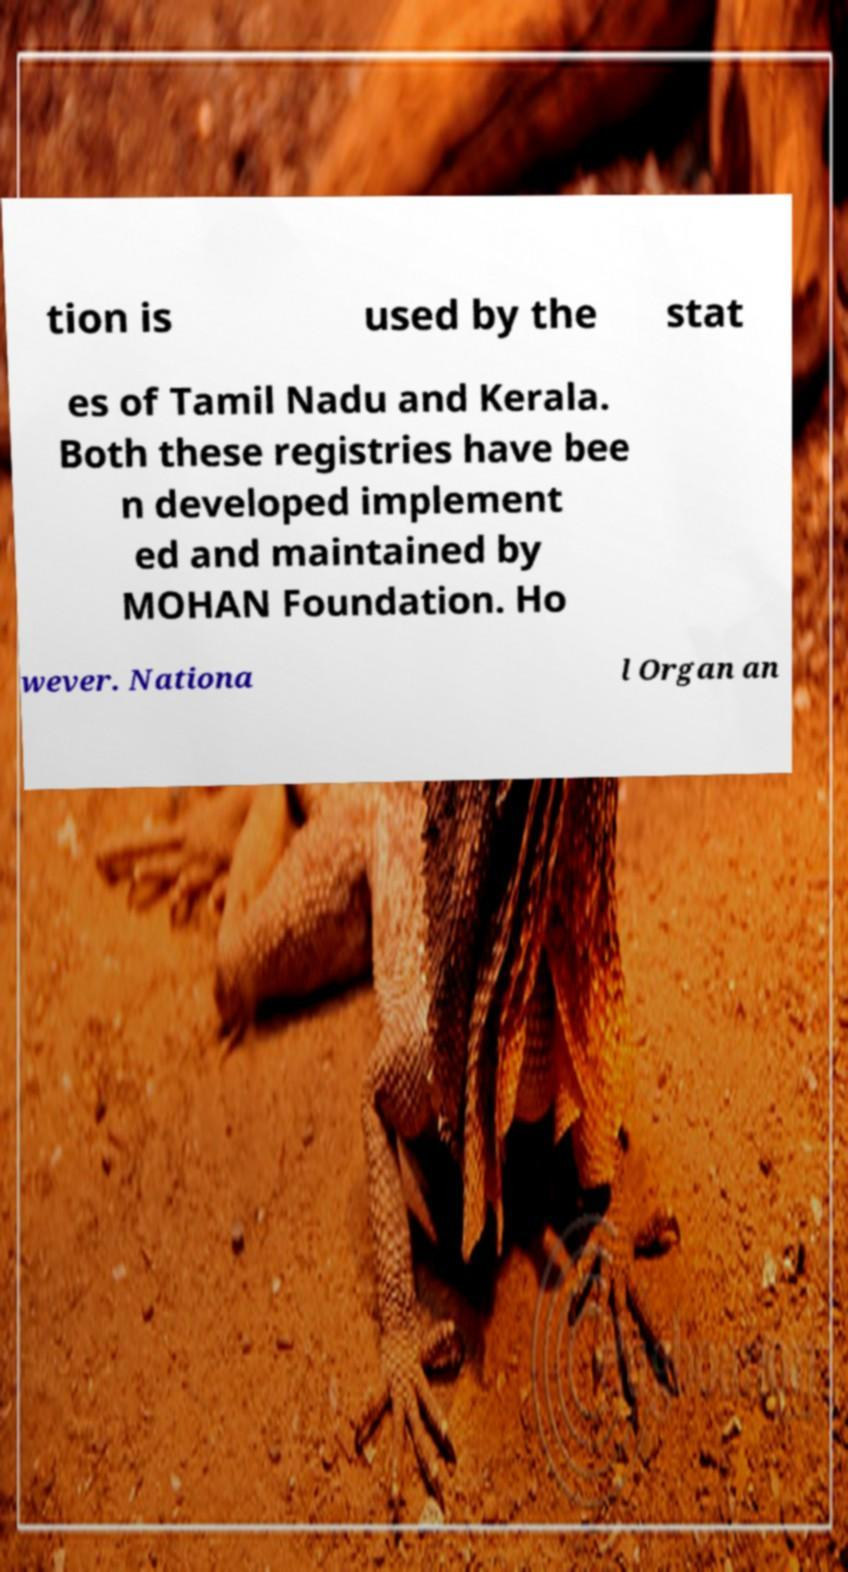Can you accurately transcribe the text from the provided image for me? tion is used by the stat es of Tamil Nadu and Kerala. Both these registries have bee n developed implement ed and maintained by MOHAN Foundation. Ho wever. Nationa l Organ an 